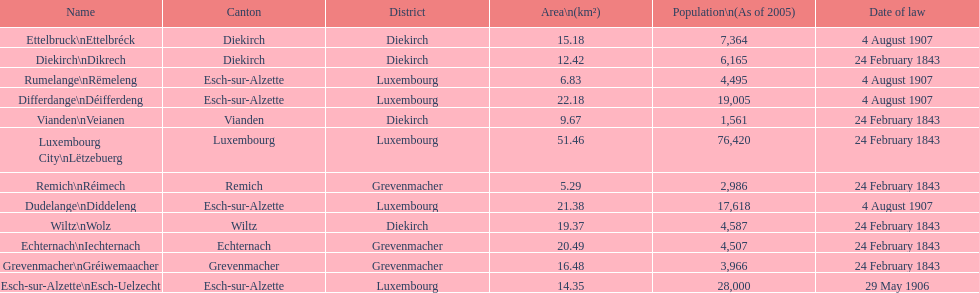Which canton falls under the date of law of 24 february 1843 and has a population of 3,966? Grevenmacher. 